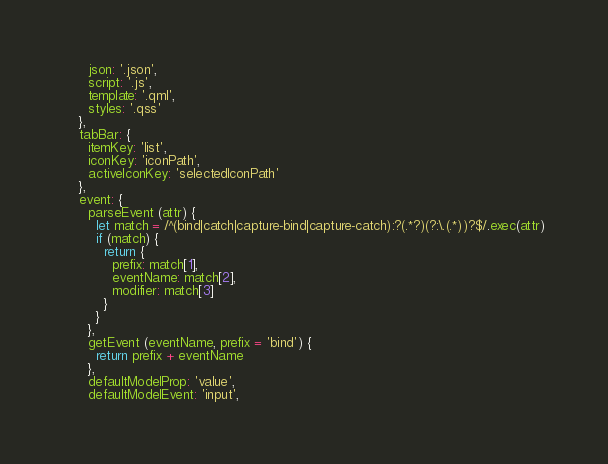<code> <loc_0><loc_0><loc_500><loc_500><_JavaScript_>      json: '.json',
      script: '.js',
      template: '.qml',
      styles: '.qss'
    },
    tabBar: {
      itemKey: 'list',
      iconKey: 'iconPath',
      activeIconKey: 'selectedIconPath'
    },
    event: {
      parseEvent (attr) {
        let match = /^(bind|catch|capture-bind|capture-catch):?(.*?)(?:\.(.*))?$/.exec(attr)
        if (match) {
          return {
            prefix: match[1],
            eventName: match[2],
            modifier: match[3]
          }
        }
      },
      getEvent (eventName, prefix = 'bind') {
        return prefix + eventName
      },
      defaultModelProp: 'value',
      defaultModelEvent: 'input',</code> 